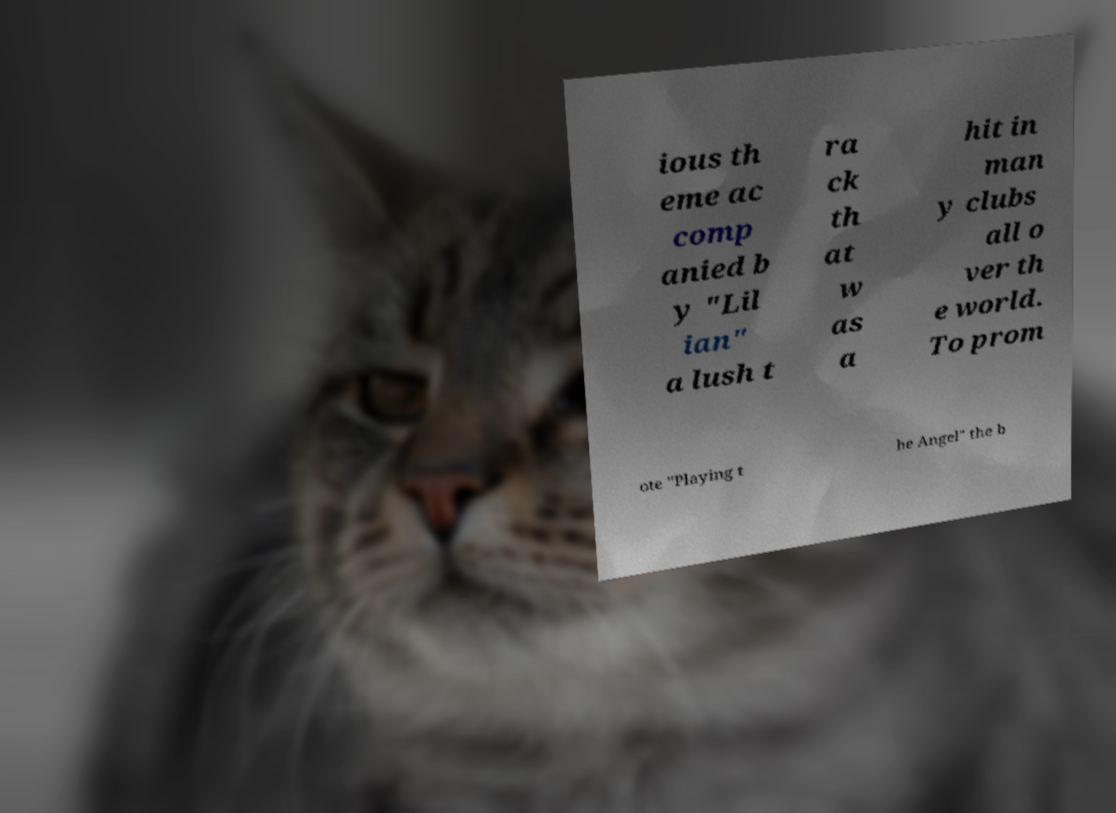Please read and relay the text visible in this image. What does it say? ious th eme ac comp anied b y "Lil ian" a lush t ra ck th at w as a hit in man y clubs all o ver th e world. To prom ote "Playing t he Angel" the b 